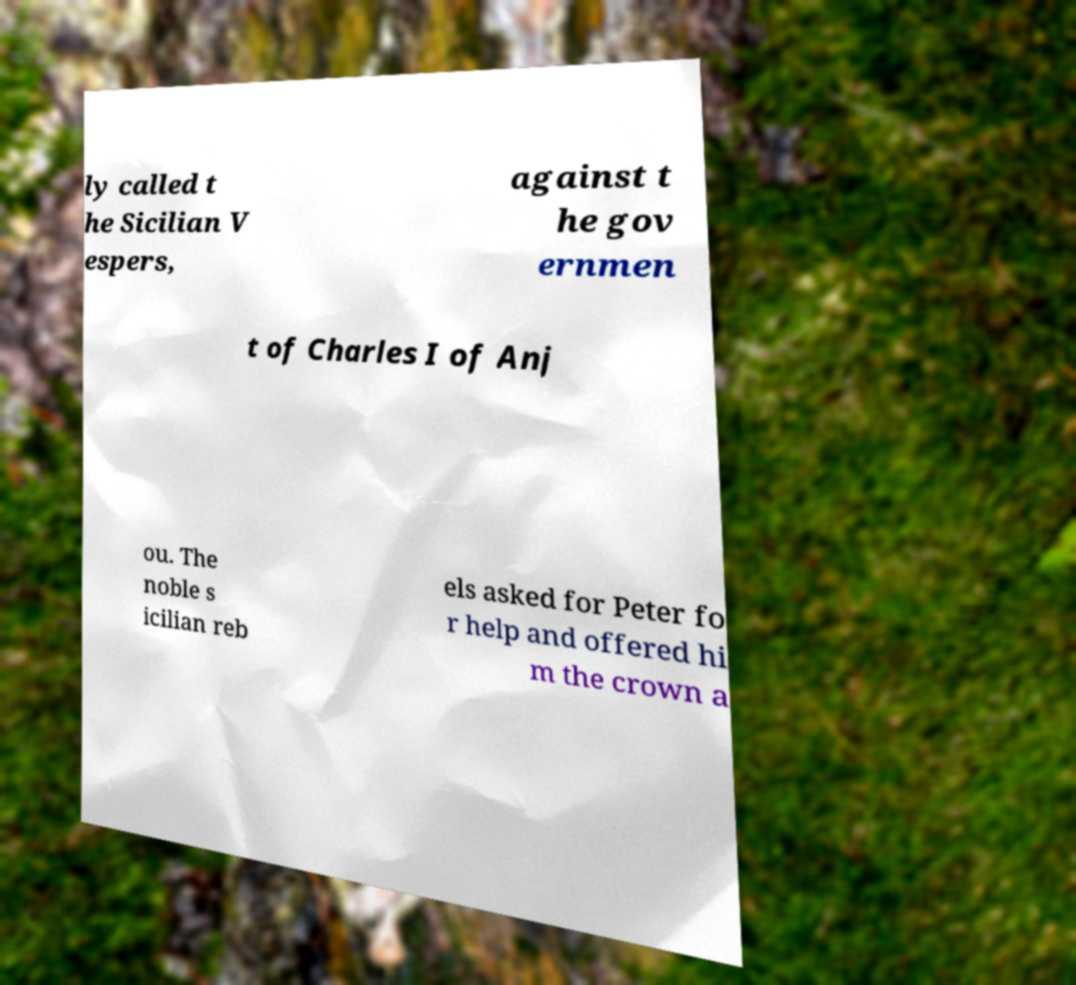I need the written content from this picture converted into text. Can you do that? ly called t he Sicilian V espers, against t he gov ernmen t of Charles I of Anj ou. The noble s icilian reb els asked for Peter fo r help and offered hi m the crown a 